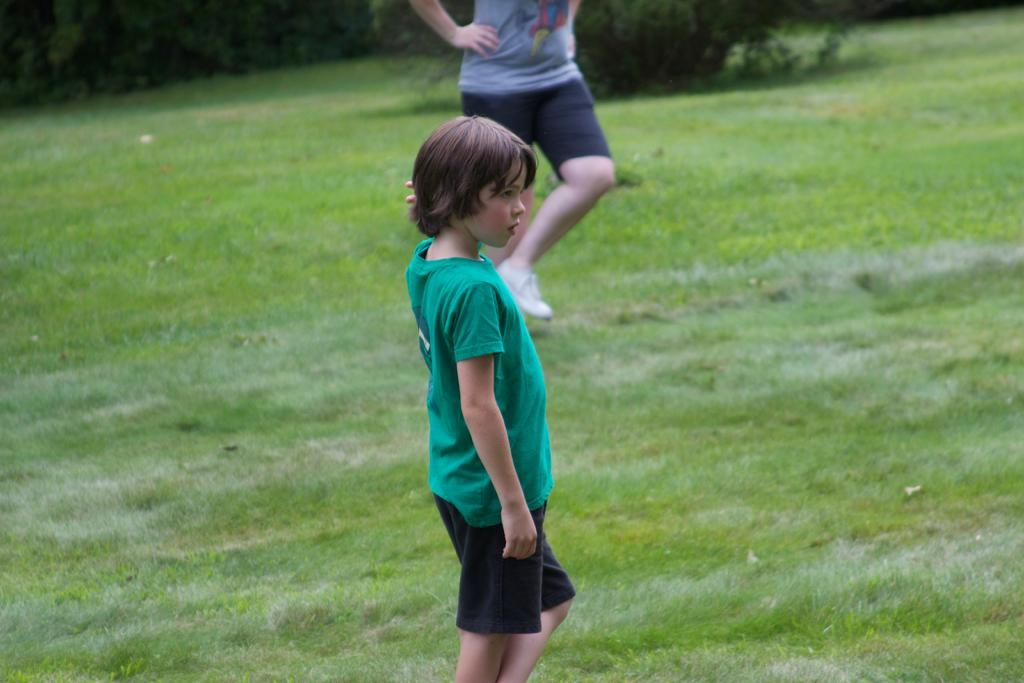What is the person in the image standing on? The person is standing on the grass. What color is the t-shirt the person is wearing? The person is wearing a green t-shirt. What type of shorts is the person wearing? The person is wearing black shorts. Can you describe the person behind the first person? There is another person behind the first person, but no specific details about their clothing or appearance are provided. What type of vegetation is visible in the background? There are trees at the back of the scene. What type of underwear is the person wearing in the image? There is no information provided about the person's underwear in the image. What type of war is depicted in the image? There is no war depicted in the image; it features a person standing on grass and wearing a green t-shirt and black shorts. What type of machine is visible in the image? There is no machine visible in the image. 